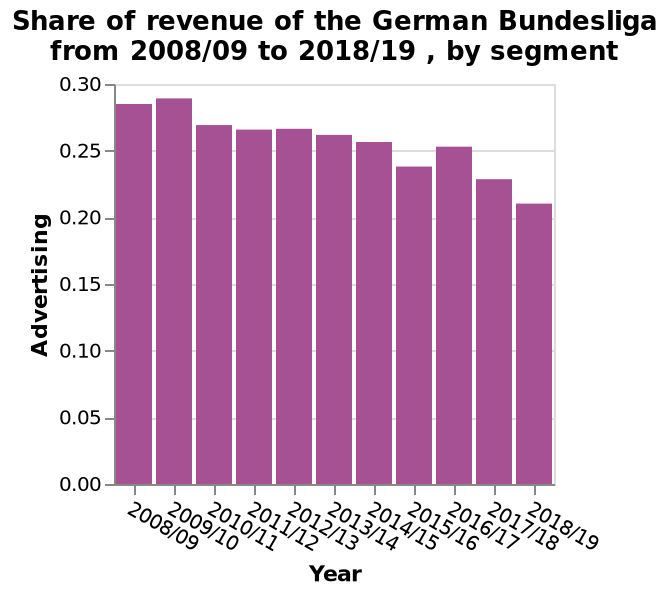<image>
What is the minimum value on the y-axis in the bar diagram?  The minimum value on the y-axis in the bar diagram is 0.00. What is the trend of the advertising share of revenue of the German Bundesliga? The trend of the advertising share of revenue of the German Bundesliga is a gradual decrease. 